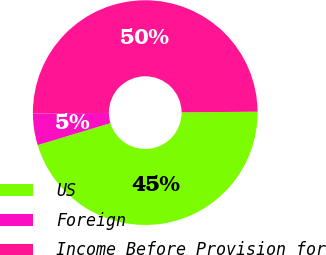Convert chart to OTSL. <chart><loc_0><loc_0><loc_500><loc_500><pie_chart><fcel>US<fcel>Foreign<fcel>Income Before Provision for<nl><fcel>45.46%<fcel>4.54%<fcel>50.0%<nl></chart> 